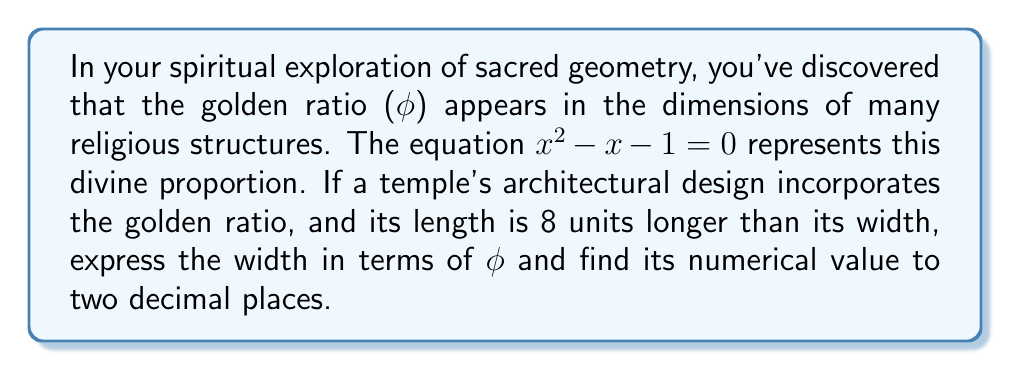Could you help me with this problem? Let's approach this step-by-step:

1) The golden ratio $\phi$ is the positive solution to the equation $x^2 - x - 1 = 0$. 

2) The quadratic formula gives us:
   $$\phi = \frac{1 + \sqrt{5}}{2} \approx 1.618034$$

3) Let $w$ be the width of the temple. The length is then $w + 8$.

4) According to the golden ratio principle:
   $$\frac{w + 8}{w} = \phi$$

5) This can be rewritten as:
   $$w + 8 = w\phi$$

6) Solving for $w$:
   $$8 = w\phi - w = w(\phi - 1)$$
   $$w = \frac{8}{\phi - 1}$$

7) We know that $\phi^2 = \phi + 1$ (from the original equation). Therefore:
   $$\phi - 1 = \frac{1}{\phi}$$

8) Substituting this back:
   $$w = 8\phi$$

9) To find the numerical value, we multiply:
   $$w = 8 \times 1.618034 \approx 12.94$$

10) Rounding to two decimal places: $w \approx 12.94$
Answer: $w = 8\phi \approx 12.94$ 